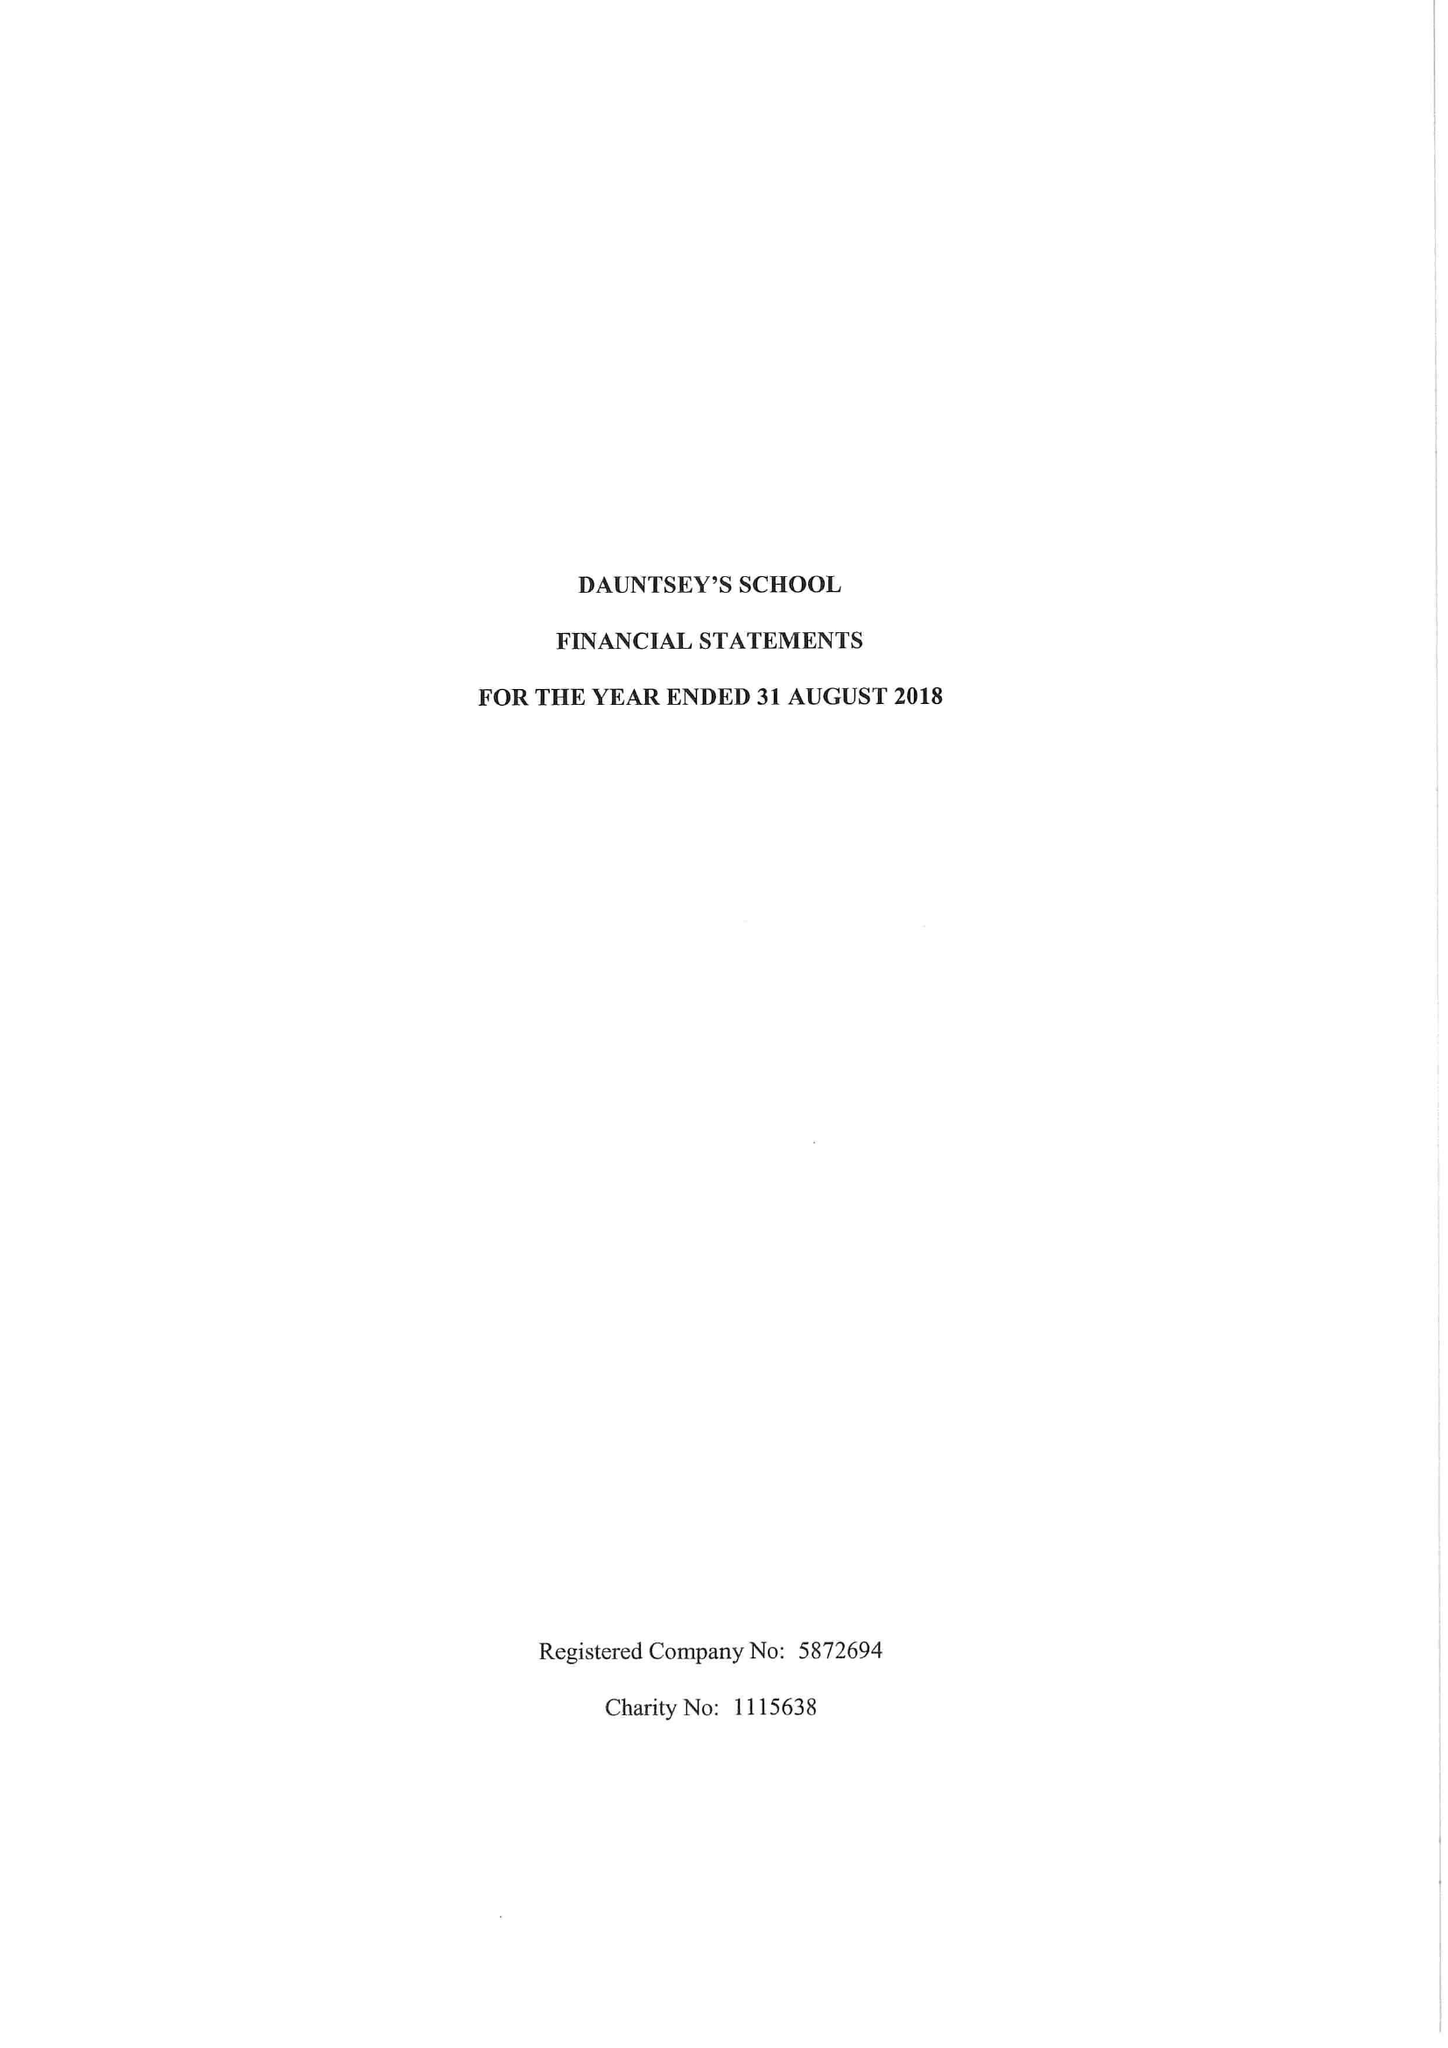What is the value for the address__post_town?
Answer the question using a single word or phrase. DEVIZES 